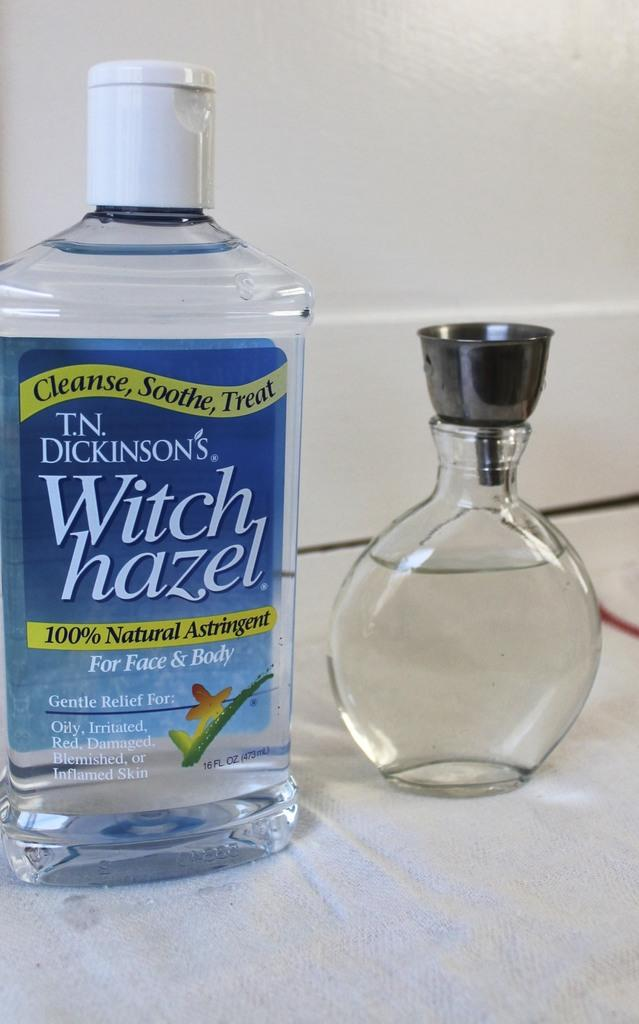<image>
Render a clear and concise summary of the photo. A bottle of T.N. Dickinson's Witch hazel next to a small vase. 